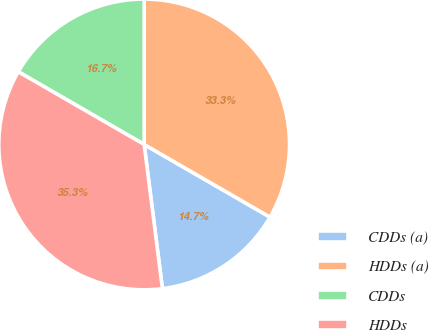Convert chart. <chart><loc_0><loc_0><loc_500><loc_500><pie_chart><fcel>CDDs (a)<fcel>HDDs (a)<fcel>CDDs<fcel>HDDs<nl><fcel>14.66%<fcel>33.33%<fcel>16.67%<fcel>35.34%<nl></chart> 